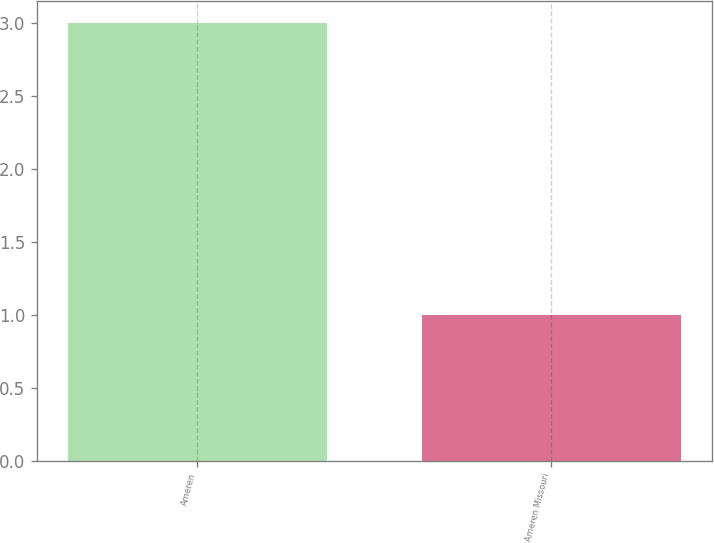<chart> <loc_0><loc_0><loc_500><loc_500><bar_chart><fcel>Ameren<fcel>Ameren Missouri<nl><fcel>3<fcel>1<nl></chart> 